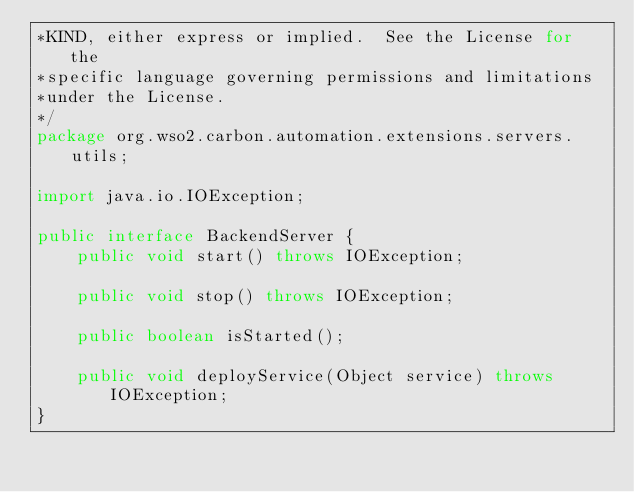Convert code to text. <code><loc_0><loc_0><loc_500><loc_500><_Java_>*KIND, either express or implied.  See the License for the
*specific language governing permissions and limitations
*under the License.
*/
package org.wso2.carbon.automation.extensions.servers.utils;

import java.io.IOException;

public interface BackendServer {
    public void start() throws IOException;

    public void stop() throws IOException;

    public boolean isStarted();

    public void deployService(Object service) throws IOException;
}
</code> 